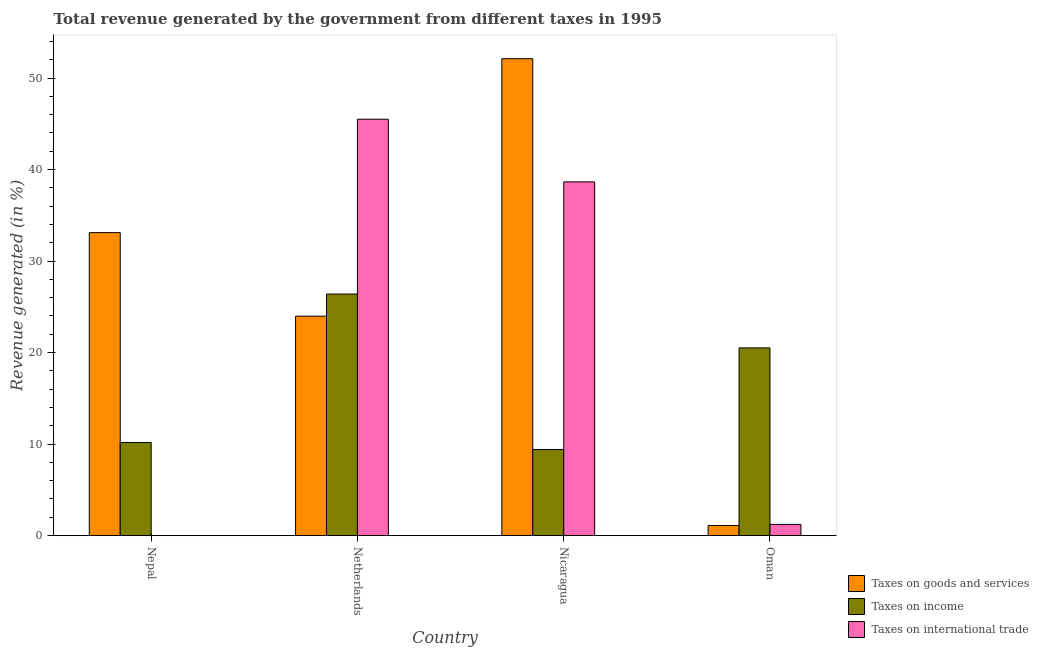Are the number of bars per tick equal to the number of legend labels?
Your answer should be very brief. Yes. How many bars are there on the 3rd tick from the left?
Give a very brief answer. 3. What is the label of the 4th group of bars from the left?
Your answer should be compact. Oman. What is the percentage of revenue generated by taxes on goods and services in Nepal?
Make the answer very short. 33.11. Across all countries, what is the maximum percentage of revenue generated by taxes on income?
Keep it short and to the point. 26.4. Across all countries, what is the minimum percentage of revenue generated by taxes on goods and services?
Give a very brief answer. 1.1. In which country was the percentage of revenue generated by taxes on income minimum?
Your response must be concise. Nicaragua. What is the total percentage of revenue generated by tax on international trade in the graph?
Your answer should be compact. 85.38. What is the difference between the percentage of revenue generated by tax on international trade in Nepal and that in Netherlands?
Make the answer very short. -45.49. What is the difference between the percentage of revenue generated by tax on international trade in Netherlands and the percentage of revenue generated by taxes on goods and services in Nicaragua?
Make the answer very short. -6.61. What is the average percentage of revenue generated by taxes on income per country?
Offer a terse response. 16.62. What is the difference between the percentage of revenue generated by tax on international trade and percentage of revenue generated by taxes on goods and services in Nicaragua?
Your answer should be very brief. -13.46. What is the ratio of the percentage of revenue generated by taxes on goods and services in Nepal to that in Netherlands?
Keep it short and to the point. 1.38. What is the difference between the highest and the second highest percentage of revenue generated by tax on international trade?
Offer a very short reply. 6.84. What is the difference between the highest and the lowest percentage of revenue generated by taxes on income?
Provide a succinct answer. 16.99. Is the sum of the percentage of revenue generated by taxes on goods and services in Nepal and Nicaragua greater than the maximum percentage of revenue generated by taxes on income across all countries?
Provide a short and direct response. Yes. What does the 1st bar from the left in Nepal represents?
Offer a very short reply. Taxes on goods and services. What does the 1st bar from the right in Nicaragua represents?
Your answer should be very brief. Taxes on international trade. Is it the case that in every country, the sum of the percentage of revenue generated by taxes on goods and services and percentage of revenue generated by taxes on income is greater than the percentage of revenue generated by tax on international trade?
Offer a very short reply. Yes. How many countries are there in the graph?
Your response must be concise. 4. Does the graph contain any zero values?
Keep it short and to the point. No. Does the graph contain grids?
Your answer should be compact. No. Where does the legend appear in the graph?
Give a very brief answer. Bottom right. How many legend labels are there?
Provide a short and direct response. 3. What is the title of the graph?
Give a very brief answer. Total revenue generated by the government from different taxes in 1995. What is the label or title of the X-axis?
Your answer should be very brief. Country. What is the label or title of the Y-axis?
Your response must be concise. Revenue generated (in %). What is the Revenue generated (in %) in Taxes on goods and services in Nepal?
Offer a terse response. 33.11. What is the Revenue generated (in %) of Taxes on income in Nepal?
Keep it short and to the point. 10.17. What is the Revenue generated (in %) of Taxes on international trade in Nepal?
Offer a terse response. 0. What is the Revenue generated (in %) of Taxes on goods and services in Netherlands?
Keep it short and to the point. 23.98. What is the Revenue generated (in %) in Taxes on income in Netherlands?
Provide a short and direct response. 26.4. What is the Revenue generated (in %) in Taxes on international trade in Netherlands?
Ensure brevity in your answer.  45.5. What is the Revenue generated (in %) in Taxes on goods and services in Nicaragua?
Give a very brief answer. 52.11. What is the Revenue generated (in %) of Taxes on income in Nicaragua?
Keep it short and to the point. 9.4. What is the Revenue generated (in %) of Taxes on international trade in Nicaragua?
Make the answer very short. 38.65. What is the Revenue generated (in %) in Taxes on goods and services in Oman?
Offer a terse response. 1.1. What is the Revenue generated (in %) of Taxes on income in Oman?
Ensure brevity in your answer.  20.51. What is the Revenue generated (in %) in Taxes on international trade in Oman?
Make the answer very short. 1.22. Across all countries, what is the maximum Revenue generated (in %) of Taxes on goods and services?
Provide a short and direct response. 52.11. Across all countries, what is the maximum Revenue generated (in %) in Taxes on income?
Provide a short and direct response. 26.4. Across all countries, what is the maximum Revenue generated (in %) of Taxes on international trade?
Offer a very short reply. 45.5. Across all countries, what is the minimum Revenue generated (in %) in Taxes on goods and services?
Keep it short and to the point. 1.1. Across all countries, what is the minimum Revenue generated (in %) in Taxes on income?
Your answer should be very brief. 9.4. Across all countries, what is the minimum Revenue generated (in %) in Taxes on international trade?
Provide a short and direct response. 0. What is the total Revenue generated (in %) in Taxes on goods and services in the graph?
Your answer should be very brief. 110.3. What is the total Revenue generated (in %) in Taxes on income in the graph?
Your answer should be compact. 66.49. What is the total Revenue generated (in %) in Taxes on international trade in the graph?
Offer a terse response. 85.38. What is the difference between the Revenue generated (in %) in Taxes on goods and services in Nepal and that in Netherlands?
Your answer should be compact. 9.13. What is the difference between the Revenue generated (in %) in Taxes on income in Nepal and that in Netherlands?
Keep it short and to the point. -16.22. What is the difference between the Revenue generated (in %) of Taxes on international trade in Nepal and that in Netherlands?
Provide a succinct answer. -45.49. What is the difference between the Revenue generated (in %) of Taxes on goods and services in Nepal and that in Nicaragua?
Ensure brevity in your answer.  -19.01. What is the difference between the Revenue generated (in %) in Taxes on income in Nepal and that in Nicaragua?
Your response must be concise. 0.77. What is the difference between the Revenue generated (in %) of Taxes on international trade in Nepal and that in Nicaragua?
Offer a terse response. -38.65. What is the difference between the Revenue generated (in %) of Taxes on goods and services in Nepal and that in Oman?
Provide a short and direct response. 32.01. What is the difference between the Revenue generated (in %) of Taxes on income in Nepal and that in Oman?
Offer a very short reply. -10.34. What is the difference between the Revenue generated (in %) in Taxes on international trade in Nepal and that in Oman?
Keep it short and to the point. -1.22. What is the difference between the Revenue generated (in %) of Taxes on goods and services in Netherlands and that in Nicaragua?
Your answer should be very brief. -28.14. What is the difference between the Revenue generated (in %) in Taxes on income in Netherlands and that in Nicaragua?
Ensure brevity in your answer.  16.99. What is the difference between the Revenue generated (in %) in Taxes on international trade in Netherlands and that in Nicaragua?
Keep it short and to the point. 6.84. What is the difference between the Revenue generated (in %) in Taxes on goods and services in Netherlands and that in Oman?
Make the answer very short. 22.88. What is the difference between the Revenue generated (in %) of Taxes on income in Netherlands and that in Oman?
Give a very brief answer. 5.89. What is the difference between the Revenue generated (in %) of Taxes on international trade in Netherlands and that in Oman?
Keep it short and to the point. 44.28. What is the difference between the Revenue generated (in %) in Taxes on goods and services in Nicaragua and that in Oman?
Give a very brief answer. 51.01. What is the difference between the Revenue generated (in %) of Taxes on income in Nicaragua and that in Oman?
Your response must be concise. -11.11. What is the difference between the Revenue generated (in %) in Taxes on international trade in Nicaragua and that in Oman?
Give a very brief answer. 37.43. What is the difference between the Revenue generated (in %) in Taxes on goods and services in Nepal and the Revenue generated (in %) in Taxes on income in Netherlands?
Offer a very short reply. 6.71. What is the difference between the Revenue generated (in %) of Taxes on goods and services in Nepal and the Revenue generated (in %) of Taxes on international trade in Netherlands?
Your answer should be compact. -12.39. What is the difference between the Revenue generated (in %) in Taxes on income in Nepal and the Revenue generated (in %) in Taxes on international trade in Netherlands?
Offer a terse response. -35.33. What is the difference between the Revenue generated (in %) in Taxes on goods and services in Nepal and the Revenue generated (in %) in Taxes on income in Nicaragua?
Ensure brevity in your answer.  23.7. What is the difference between the Revenue generated (in %) of Taxes on goods and services in Nepal and the Revenue generated (in %) of Taxes on international trade in Nicaragua?
Provide a short and direct response. -5.55. What is the difference between the Revenue generated (in %) in Taxes on income in Nepal and the Revenue generated (in %) in Taxes on international trade in Nicaragua?
Your answer should be compact. -28.48. What is the difference between the Revenue generated (in %) of Taxes on goods and services in Nepal and the Revenue generated (in %) of Taxes on income in Oman?
Offer a terse response. 12.59. What is the difference between the Revenue generated (in %) of Taxes on goods and services in Nepal and the Revenue generated (in %) of Taxes on international trade in Oman?
Offer a very short reply. 31.89. What is the difference between the Revenue generated (in %) in Taxes on income in Nepal and the Revenue generated (in %) in Taxes on international trade in Oman?
Provide a short and direct response. 8.95. What is the difference between the Revenue generated (in %) of Taxes on goods and services in Netherlands and the Revenue generated (in %) of Taxes on income in Nicaragua?
Your answer should be very brief. 14.57. What is the difference between the Revenue generated (in %) of Taxes on goods and services in Netherlands and the Revenue generated (in %) of Taxes on international trade in Nicaragua?
Ensure brevity in your answer.  -14.68. What is the difference between the Revenue generated (in %) in Taxes on income in Netherlands and the Revenue generated (in %) in Taxes on international trade in Nicaragua?
Keep it short and to the point. -12.26. What is the difference between the Revenue generated (in %) in Taxes on goods and services in Netherlands and the Revenue generated (in %) in Taxes on income in Oman?
Offer a very short reply. 3.46. What is the difference between the Revenue generated (in %) of Taxes on goods and services in Netherlands and the Revenue generated (in %) of Taxes on international trade in Oman?
Offer a very short reply. 22.76. What is the difference between the Revenue generated (in %) of Taxes on income in Netherlands and the Revenue generated (in %) of Taxes on international trade in Oman?
Your response must be concise. 25.18. What is the difference between the Revenue generated (in %) in Taxes on goods and services in Nicaragua and the Revenue generated (in %) in Taxes on income in Oman?
Provide a succinct answer. 31.6. What is the difference between the Revenue generated (in %) of Taxes on goods and services in Nicaragua and the Revenue generated (in %) of Taxes on international trade in Oman?
Your answer should be compact. 50.89. What is the difference between the Revenue generated (in %) in Taxes on income in Nicaragua and the Revenue generated (in %) in Taxes on international trade in Oman?
Your response must be concise. 8.18. What is the average Revenue generated (in %) in Taxes on goods and services per country?
Ensure brevity in your answer.  27.57. What is the average Revenue generated (in %) in Taxes on income per country?
Your answer should be compact. 16.62. What is the average Revenue generated (in %) of Taxes on international trade per country?
Ensure brevity in your answer.  21.34. What is the difference between the Revenue generated (in %) in Taxes on goods and services and Revenue generated (in %) in Taxes on income in Nepal?
Provide a succinct answer. 22.93. What is the difference between the Revenue generated (in %) in Taxes on goods and services and Revenue generated (in %) in Taxes on international trade in Nepal?
Provide a succinct answer. 33.1. What is the difference between the Revenue generated (in %) in Taxes on income and Revenue generated (in %) in Taxes on international trade in Nepal?
Your answer should be compact. 10.17. What is the difference between the Revenue generated (in %) in Taxes on goods and services and Revenue generated (in %) in Taxes on income in Netherlands?
Provide a succinct answer. -2.42. What is the difference between the Revenue generated (in %) in Taxes on goods and services and Revenue generated (in %) in Taxes on international trade in Netherlands?
Give a very brief answer. -21.52. What is the difference between the Revenue generated (in %) in Taxes on income and Revenue generated (in %) in Taxes on international trade in Netherlands?
Make the answer very short. -19.1. What is the difference between the Revenue generated (in %) in Taxes on goods and services and Revenue generated (in %) in Taxes on income in Nicaragua?
Your response must be concise. 42.71. What is the difference between the Revenue generated (in %) in Taxes on goods and services and Revenue generated (in %) in Taxes on international trade in Nicaragua?
Give a very brief answer. 13.46. What is the difference between the Revenue generated (in %) in Taxes on income and Revenue generated (in %) in Taxes on international trade in Nicaragua?
Ensure brevity in your answer.  -29.25. What is the difference between the Revenue generated (in %) in Taxes on goods and services and Revenue generated (in %) in Taxes on income in Oman?
Offer a terse response. -19.41. What is the difference between the Revenue generated (in %) in Taxes on goods and services and Revenue generated (in %) in Taxes on international trade in Oman?
Keep it short and to the point. -0.12. What is the difference between the Revenue generated (in %) in Taxes on income and Revenue generated (in %) in Taxes on international trade in Oman?
Provide a succinct answer. 19.29. What is the ratio of the Revenue generated (in %) of Taxes on goods and services in Nepal to that in Netherlands?
Give a very brief answer. 1.38. What is the ratio of the Revenue generated (in %) in Taxes on income in Nepal to that in Netherlands?
Provide a short and direct response. 0.39. What is the ratio of the Revenue generated (in %) of Taxes on goods and services in Nepal to that in Nicaragua?
Keep it short and to the point. 0.64. What is the ratio of the Revenue generated (in %) in Taxes on income in Nepal to that in Nicaragua?
Provide a short and direct response. 1.08. What is the ratio of the Revenue generated (in %) of Taxes on goods and services in Nepal to that in Oman?
Make the answer very short. 30.07. What is the ratio of the Revenue generated (in %) in Taxes on income in Nepal to that in Oman?
Provide a short and direct response. 0.5. What is the ratio of the Revenue generated (in %) of Taxes on international trade in Nepal to that in Oman?
Provide a succinct answer. 0. What is the ratio of the Revenue generated (in %) of Taxes on goods and services in Netherlands to that in Nicaragua?
Provide a succinct answer. 0.46. What is the ratio of the Revenue generated (in %) of Taxes on income in Netherlands to that in Nicaragua?
Your response must be concise. 2.81. What is the ratio of the Revenue generated (in %) in Taxes on international trade in Netherlands to that in Nicaragua?
Keep it short and to the point. 1.18. What is the ratio of the Revenue generated (in %) in Taxes on goods and services in Netherlands to that in Oman?
Give a very brief answer. 21.77. What is the ratio of the Revenue generated (in %) in Taxes on income in Netherlands to that in Oman?
Ensure brevity in your answer.  1.29. What is the ratio of the Revenue generated (in %) in Taxes on international trade in Netherlands to that in Oman?
Your answer should be very brief. 37.27. What is the ratio of the Revenue generated (in %) of Taxes on goods and services in Nicaragua to that in Oman?
Keep it short and to the point. 47.33. What is the ratio of the Revenue generated (in %) of Taxes on income in Nicaragua to that in Oman?
Make the answer very short. 0.46. What is the ratio of the Revenue generated (in %) of Taxes on international trade in Nicaragua to that in Oman?
Your response must be concise. 31.67. What is the difference between the highest and the second highest Revenue generated (in %) of Taxes on goods and services?
Provide a short and direct response. 19.01. What is the difference between the highest and the second highest Revenue generated (in %) of Taxes on income?
Make the answer very short. 5.89. What is the difference between the highest and the second highest Revenue generated (in %) of Taxes on international trade?
Offer a very short reply. 6.84. What is the difference between the highest and the lowest Revenue generated (in %) of Taxes on goods and services?
Keep it short and to the point. 51.01. What is the difference between the highest and the lowest Revenue generated (in %) in Taxes on income?
Your answer should be compact. 16.99. What is the difference between the highest and the lowest Revenue generated (in %) of Taxes on international trade?
Your answer should be compact. 45.49. 